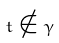<formula> <loc_0><loc_0><loc_500><loc_500>t \notin \gamma</formula> 